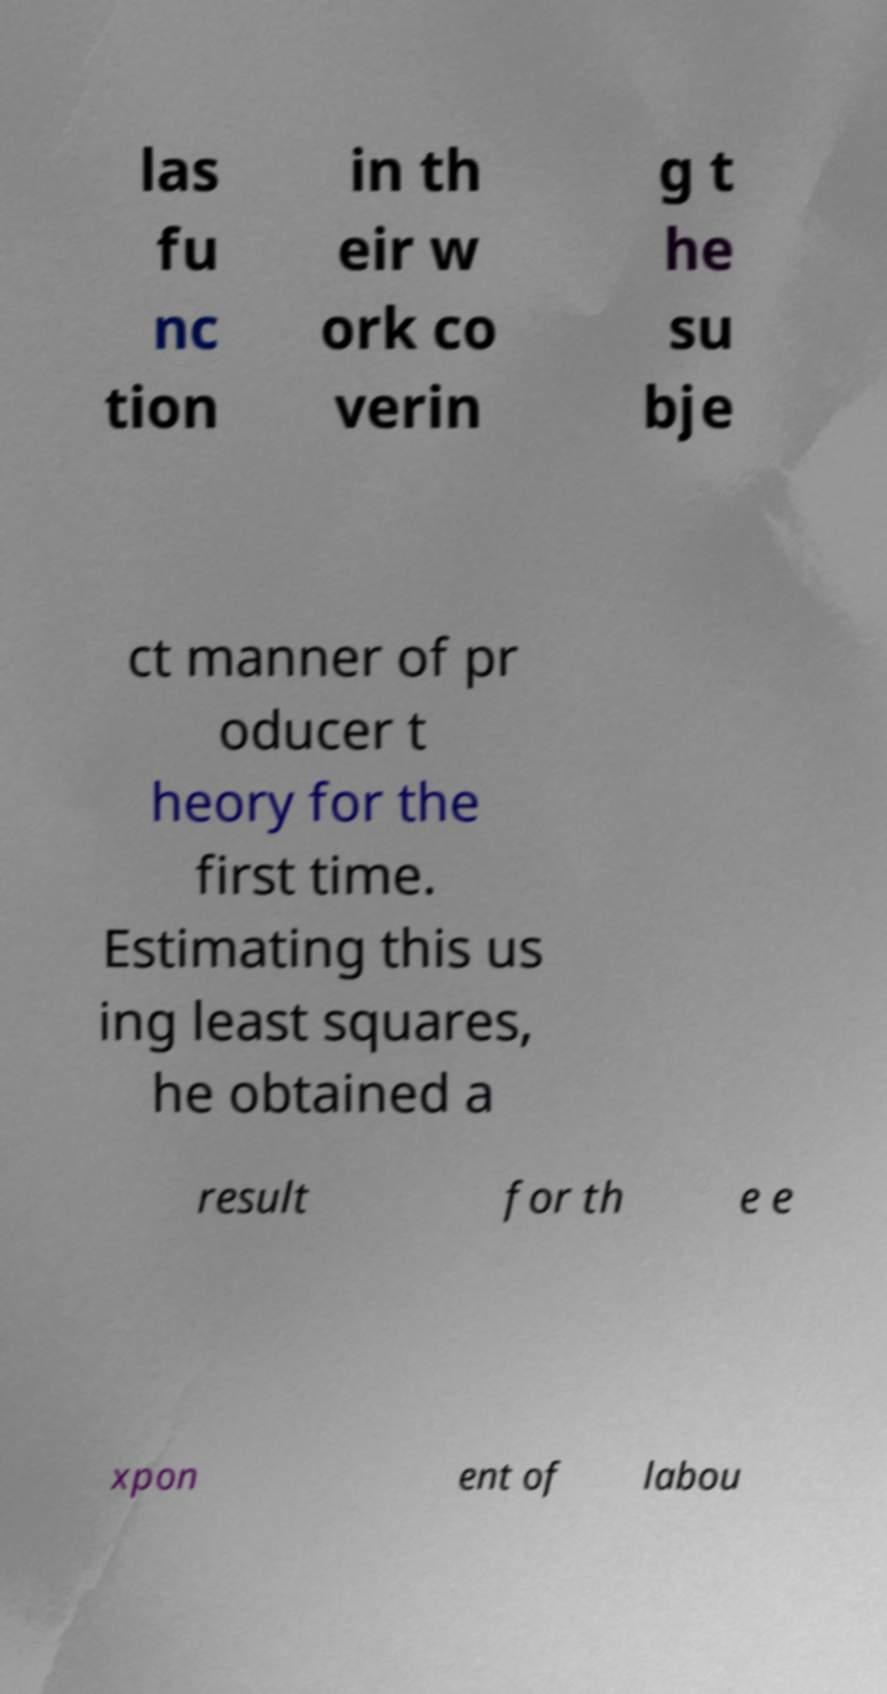For documentation purposes, I need the text within this image transcribed. Could you provide that? las fu nc tion in th eir w ork co verin g t he su bje ct manner of pr oducer t heory for the first time. Estimating this us ing least squares, he obtained a result for th e e xpon ent of labou 